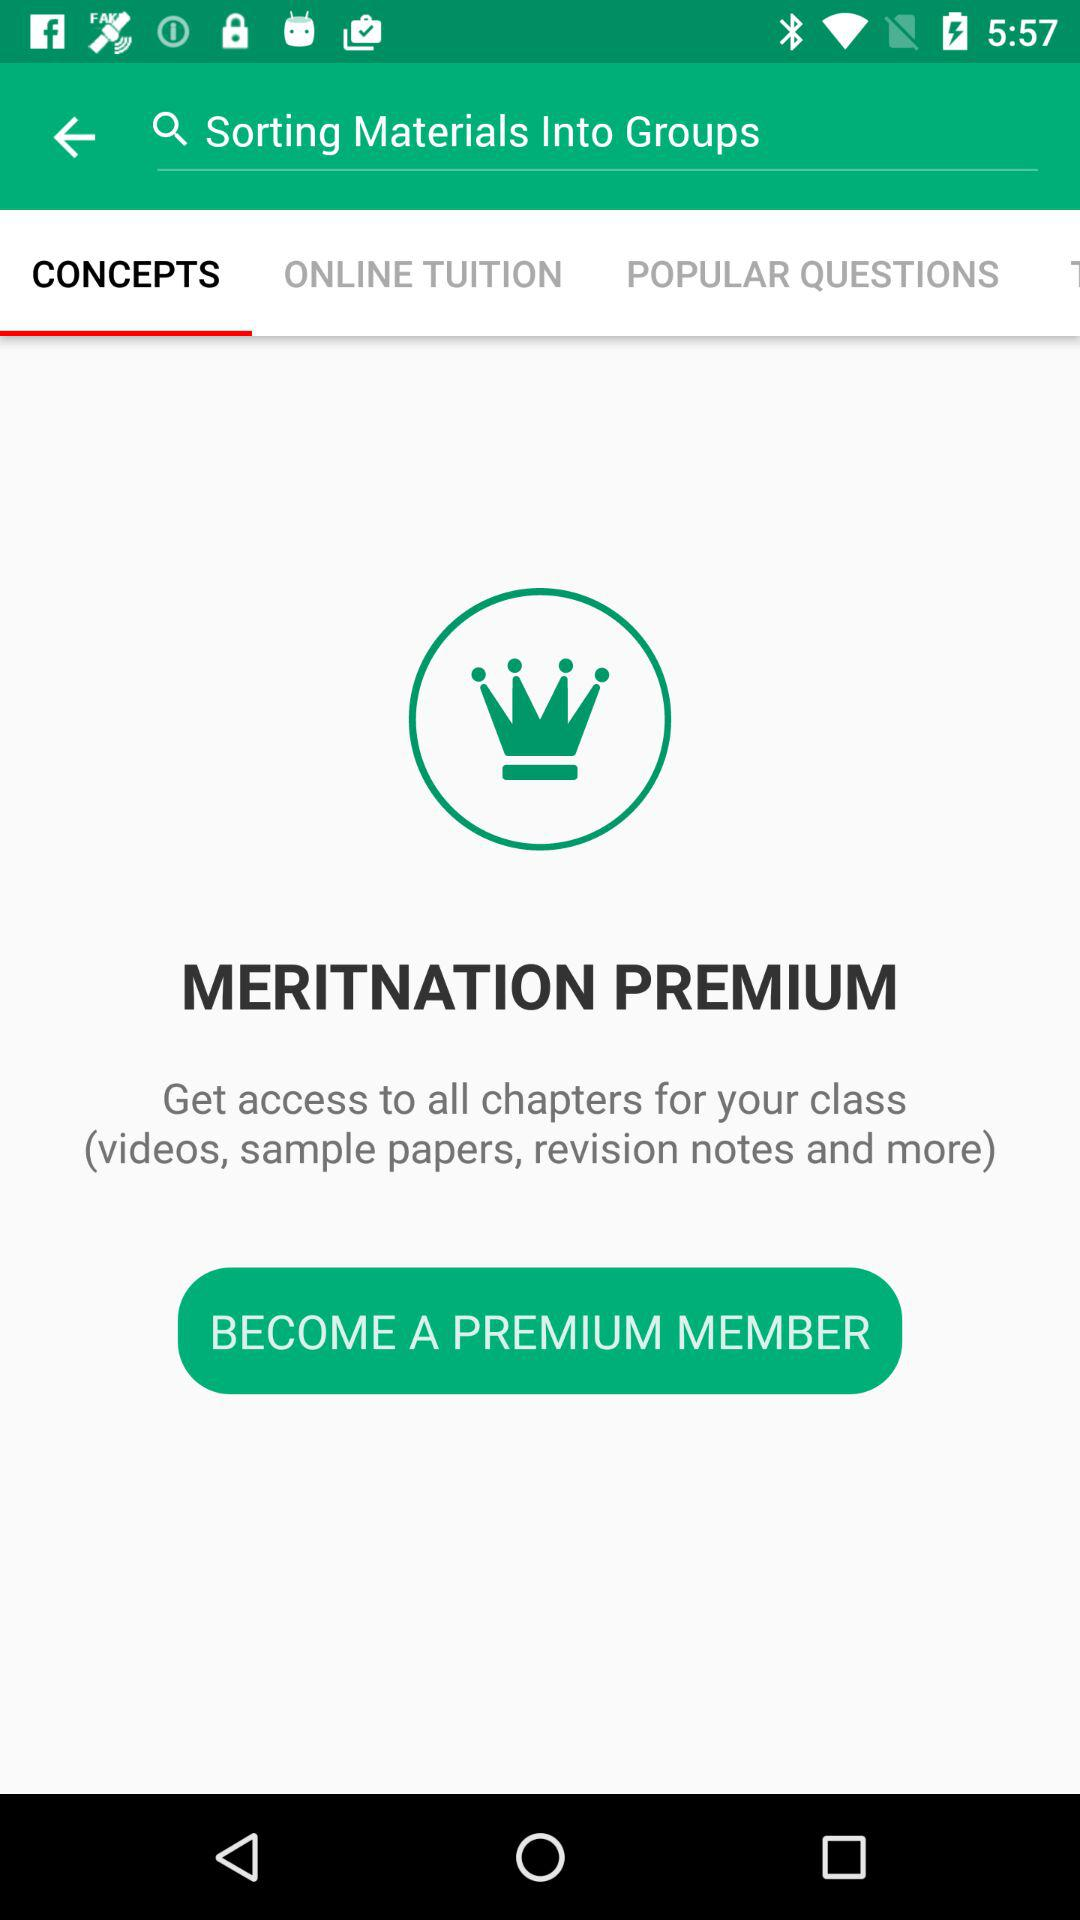Which option is selected? The selected option is "CONCEPTS". 